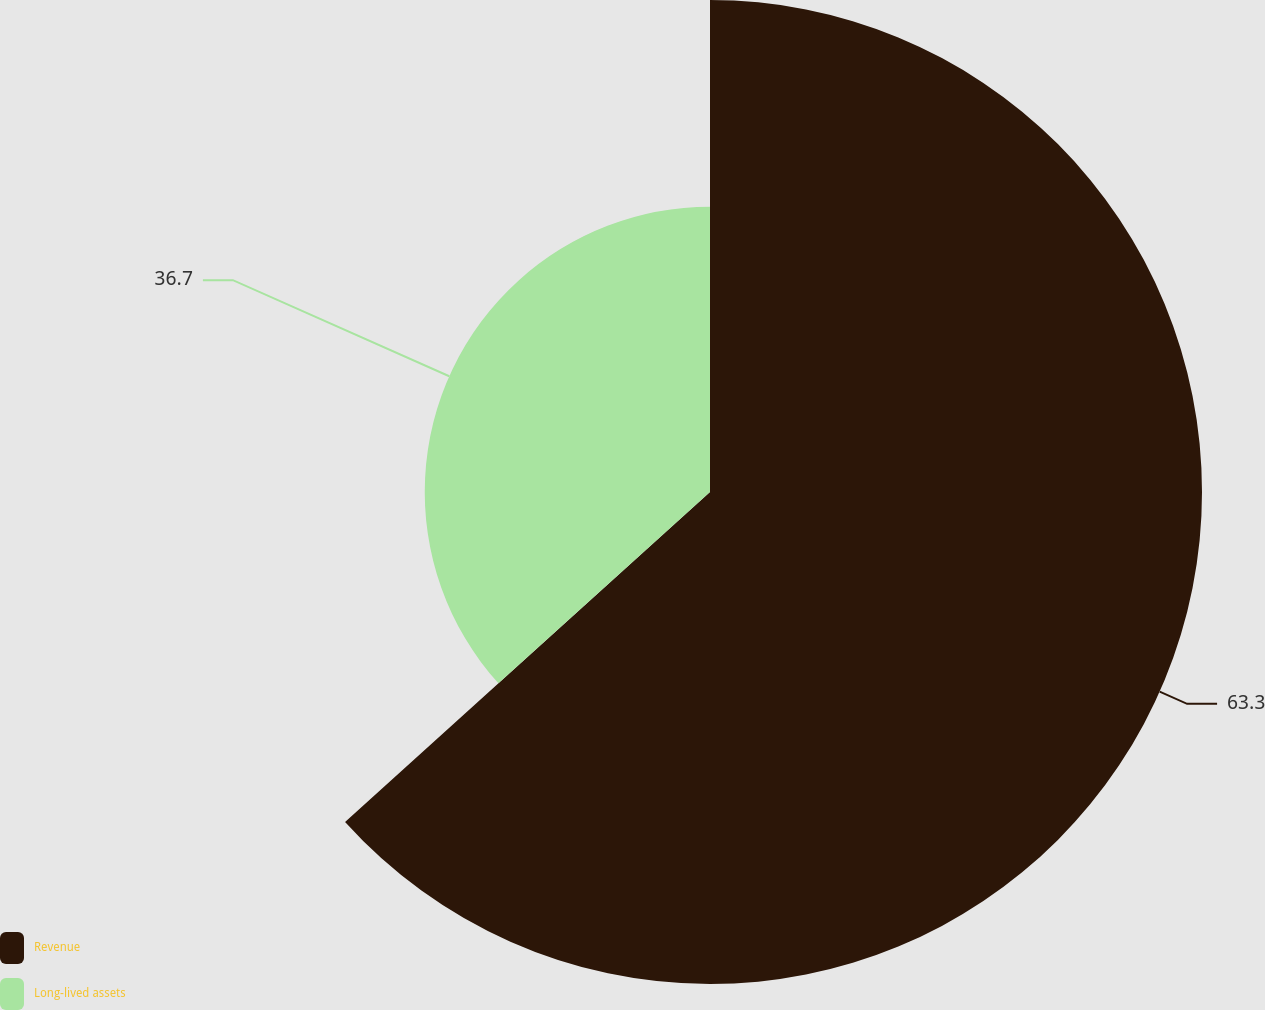Convert chart. <chart><loc_0><loc_0><loc_500><loc_500><pie_chart><fcel>Revenue<fcel>Long-lived assets<nl><fcel>63.3%<fcel>36.7%<nl></chart> 